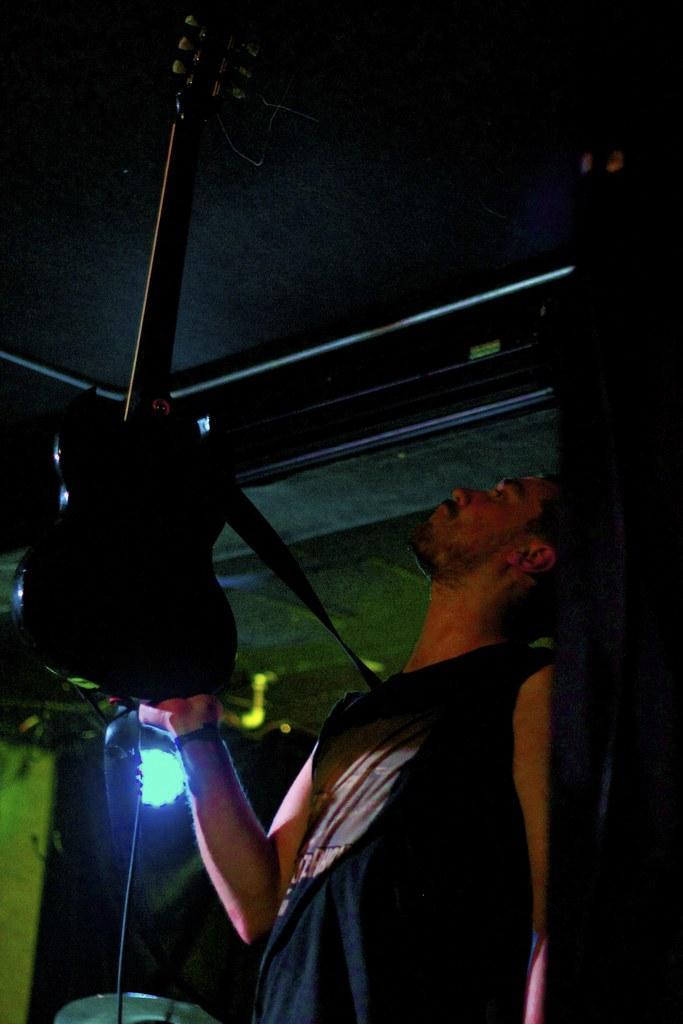In one or two sentences, can you explain what this image depicts? In this image, we can see a person holding a guitar. Background we can see light, ceiling and few objects. 